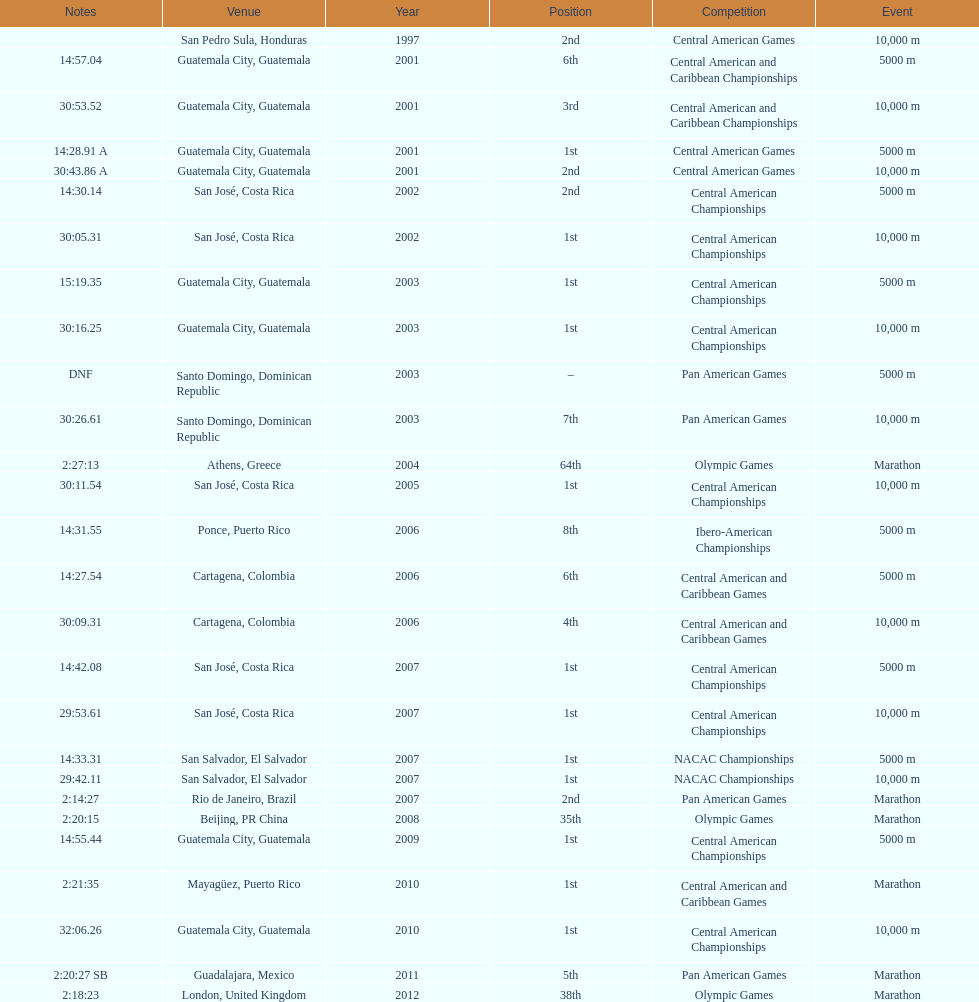Could you parse the entire table as a dict? {'header': ['Notes', 'Venue', 'Year', 'Position', 'Competition', 'Event'], 'rows': [['', 'San Pedro Sula, Honduras', '1997', '2nd', 'Central American Games', '10,000 m'], ['14:57.04', 'Guatemala City, Guatemala', '2001', '6th', 'Central American and Caribbean Championships', '5000 m'], ['30:53.52', 'Guatemala City, Guatemala', '2001', '3rd', 'Central American and Caribbean Championships', '10,000 m'], ['14:28.91 A', 'Guatemala City, Guatemala', '2001', '1st', 'Central American Games', '5000 m'], ['30:43.86 A', 'Guatemala City, Guatemala', '2001', '2nd', 'Central American Games', '10,000 m'], ['14:30.14', 'San José, Costa Rica', '2002', '2nd', 'Central American Championships', '5000 m'], ['30:05.31', 'San José, Costa Rica', '2002', '1st', 'Central American Championships', '10,000 m'], ['15:19.35', 'Guatemala City, Guatemala', '2003', '1st', 'Central American Championships', '5000 m'], ['30:16.25', 'Guatemala City, Guatemala', '2003', '1st', 'Central American Championships', '10,000 m'], ['DNF', 'Santo Domingo, Dominican Republic', '2003', '–', 'Pan American Games', '5000 m'], ['30:26.61', 'Santo Domingo, Dominican Republic', '2003', '7th', 'Pan American Games', '10,000 m'], ['2:27:13', 'Athens, Greece', '2004', '64th', 'Olympic Games', 'Marathon'], ['30:11.54', 'San José, Costa Rica', '2005', '1st', 'Central American Championships', '10,000 m'], ['14:31.55', 'Ponce, Puerto Rico', '2006', '8th', 'Ibero-American Championships', '5000 m'], ['14:27.54', 'Cartagena, Colombia', '2006', '6th', 'Central American and Caribbean Games', '5000 m'], ['30:09.31', 'Cartagena, Colombia', '2006', '4th', 'Central American and Caribbean Games', '10,000 m'], ['14:42.08', 'San José, Costa Rica', '2007', '1st', 'Central American Championships', '5000 m'], ['29:53.61', 'San José, Costa Rica', '2007', '1st', 'Central American Championships', '10,000 m'], ['14:33.31', 'San Salvador, El Salvador', '2007', '1st', 'NACAC Championships', '5000 m'], ['29:42.11', 'San Salvador, El Salvador', '2007', '1st', 'NACAC Championships', '10,000 m'], ['2:14:27', 'Rio de Janeiro, Brazil', '2007', '2nd', 'Pan American Games', 'Marathon'], ['2:20:15', 'Beijing, PR China', '2008', '35th', 'Olympic Games', 'Marathon'], ['14:55.44', 'Guatemala City, Guatemala', '2009', '1st', 'Central American Championships', '5000 m'], ['2:21:35', 'Mayagüez, Puerto Rico', '2010', '1st', 'Central American and Caribbean Games', 'Marathon'], ['32:06.26', 'Guatemala City, Guatemala', '2010', '1st', 'Central American Championships', '10,000 m'], ['2:20:27 SB', 'Guadalajara, Mexico', '2011', '5th', 'Pan American Games', 'Marathon'], ['2:18:23', 'London, United Kingdom', '2012', '38th', 'Olympic Games', 'Marathon']]} Which of each game in 2007 was in the 2nd position? Pan American Games. 